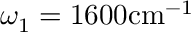<formula> <loc_0><loc_0><loc_500><loc_500>\omega _ { 1 } = 1 6 0 0 c m ^ { - 1 }</formula> 